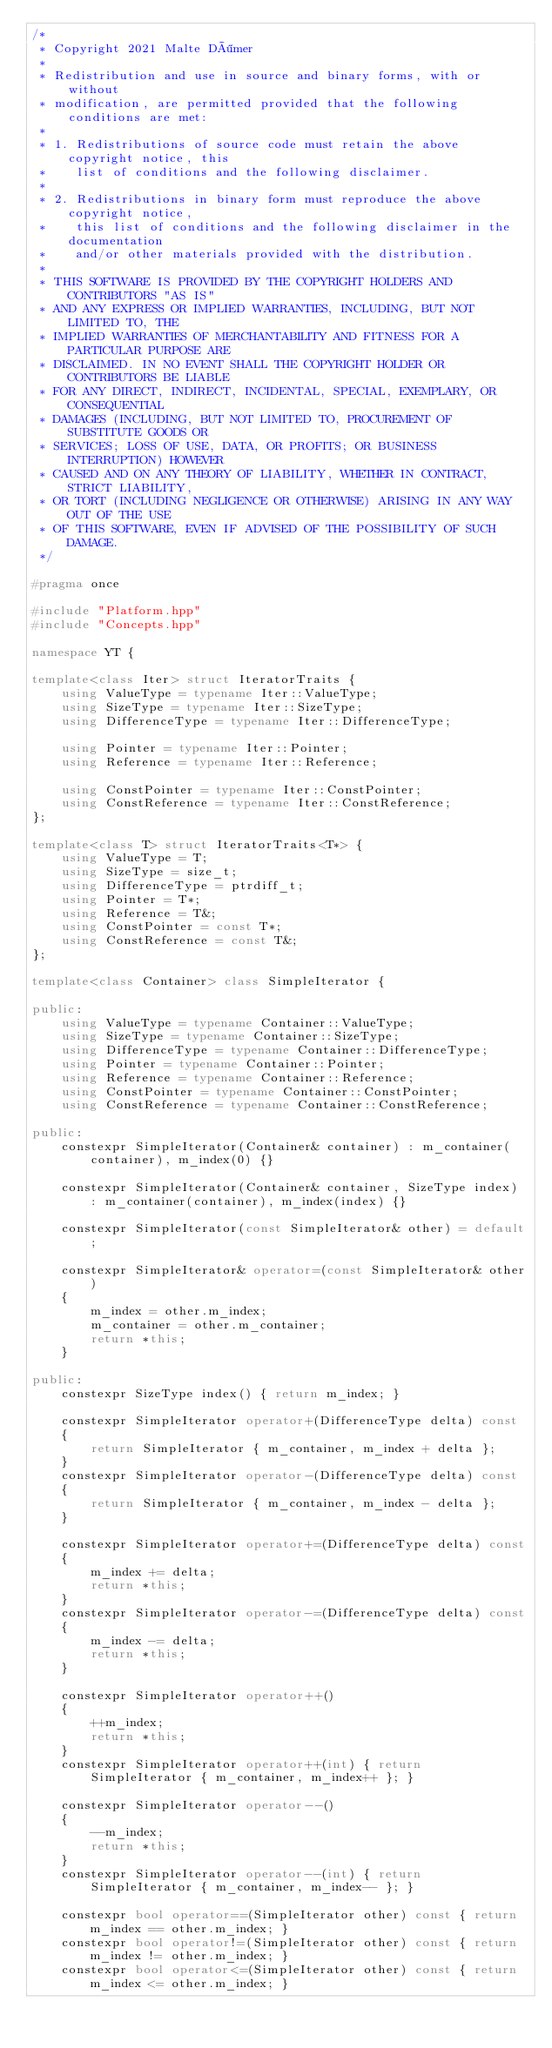Convert code to text. <code><loc_0><loc_0><loc_500><loc_500><_C++_>/*
 * Copyright 2021 Malte Dömer
 *
 * Redistribution and use in source and binary forms, with or without
 * modification, are permitted provided that the following conditions are met:
 *
 * 1. Redistributions of source code must retain the above copyright notice, this
 *    list of conditions and the following disclaimer.
 *
 * 2. Redistributions in binary form must reproduce the above copyright notice,
 *    this list of conditions and the following disclaimer in the documentation
 *    and/or other materials provided with the distribution.
 *
 * THIS SOFTWARE IS PROVIDED BY THE COPYRIGHT HOLDERS AND CONTRIBUTORS "AS IS"
 * AND ANY EXPRESS OR IMPLIED WARRANTIES, INCLUDING, BUT NOT LIMITED TO, THE
 * IMPLIED WARRANTIES OF MERCHANTABILITY AND FITNESS FOR A PARTICULAR PURPOSE ARE
 * DISCLAIMED. IN NO EVENT SHALL THE COPYRIGHT HOLDER OR CONTRIBUTORS BE LIABLE
 * FOR ANY DIRECT, INDIRECT, INCIDENTAL, SPECIAL, EXEMPLARY, OR CONSEQUENTIAL
 * DAMAGES (INCLUDING, BUT NOT LIMITED TO, PROCUREMENT OF SUBSTITUTE GOODS OR
 * SERVICES; LOSS OF USE, DATA, OR PROFITS; OR BUSINESS INTERRUPTION) HOWEVER
 * CAUSED AND ON ANY THEORY OF LIABILITY, WHETHER IN CONTRACT, STRICT LIABILITY,
 * OR TORT (INCLUDING NEGLIGENCE OR OTHERWISE) ARISING IN ANY WAY OUT OF THE USE
 * OF THIS SOFTWARE, EVEN IF ADVISED OF THE POSSIBILITY OF SUCH DAMAGE.
 */

#pragma once

#include "Platform.hpp"
#include "Concepts.hpp"

namespace YT {

template<class Iter> struct IteratorTraits {
    using ValueType = typename Iter::ValueType;
    using SizeType = typename Iter::SizeType;
    using DifferenceType = typename Iter::DifferenceType;

    using Pointer = typename Iter::Pointer;
    using Reference = typename Iter::Reference;

    using ConstPointer = typename Iter::ConstPointer;
    using ConstReference = typename Iter::ConstReference;
};

template<class T> struct IteratorTraits<T*> {
    using ValueType = T;
    using SizeType = size_t;
    using DifferenceType = ptrdiff_t;
    using Pointer = T*;
    using Reference = T&;
    using ConstPointer = const T*;
    using ConstReference = const T&;
};

template<class Container> class SimpleIterator {

public:
    using ValueType = typename Container::ValueType;
    using SizeType = typename Container::SizeType;
    using DifferenceType = typename Container::DifferenceType;
    using Pointer = typename Container::Pointer;
    using Reference = typename Container::Reference;
    using ConstPointer = typename Container::ConstPointer;
    using ConstReference = typename Container::ConstReference;

public:
    constexpr SimpleIterator(Container& container) : m_container(container), m_index(0) {}

    constexpr SimpleIterator(Container& container, SizeType index) : m_container(container), m_index(index) {}

    constexpr SimpleIterator(const SimpleIterator& other) = default;

    constexpr SimpleIterator& operator=(const SimpleIterator& other)
    {
        m_index = other.m_index;
        m_container = other.m_container;
        return *this;
    }

public:
    constexpr SizeType index() { return m_index; }

    constexpr SimpleIterator operator+(DifferenceType delta) const
    {
        return SimpleIterator { m_container, m_index + delta };
    }
    constexpr SimpleIterator operator-(DifferenceType delta) const
    {
        return SimpleIterator { m_container, m_index - delta };
    }

    constexpr SimpleIterator operator+=(DifferenceType delta) const
    {
        m_index += delta;
        return *this;
    }
    constexpr SimpleIterator operator-=(DifferenceType delta) const
    {
        m_index -= delta;
        return *this;
    }

    constexpr SimpleIterator operator++()
    {
        ++m_index;
        return *this;
    }
    constexpr SimpleIterator operator++(int) { return SimpleIterator { m_container, m_index++ }; }

    constexpr SimpleIterator operator--()
    {
        --m_index;
        return *this;
    }
    constexpr SimpleIterator operator--(int) { return SimpleIterator { m_container, m_index-- }; }

    constexpr bool operator==(SimpleIterator other) const { return m_index == other.m_index; }
    constexpr bool operator!=(SimpleIterator other) const { return m_index != other.m_index; }
    constexpr bool operator<=(SimpleIterator other) const { return m_index <= other.m_index; }</code> 